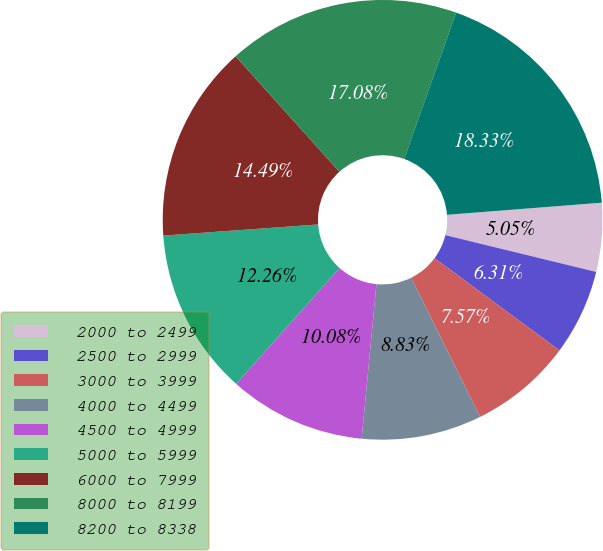<chart> <loc_0><loc_0><loc_500><loc_500><pie_chart><fcel>2000 to 2499<fcel>2500 to 2999<fcel>3000 to 3999<fcel>4000 to 4499<fcel>4500 to 4999<fcel>5000 to 5999<fcel>6000 to 7999<fcel>8000 to 8199<fcel>8200 to 8338<nl><fcel>5.05%<fcel>6.31%<fcel>7.57%<fcel>8.83%<fcel>10.08%<fcel>12.26%<fcel>14.49%<fcel>17.08%<fcel>18.33%<nl></chart> 